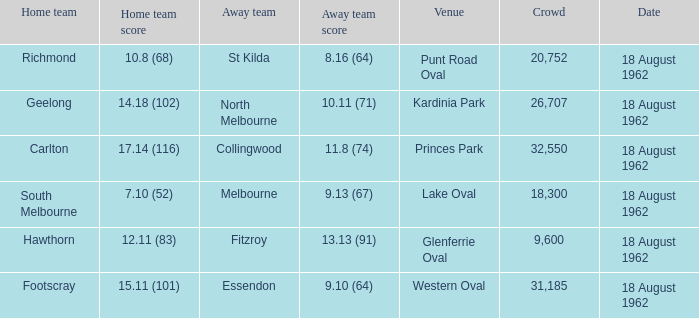What was the home team when the away team scored 9.10 (64)? Footscray. 